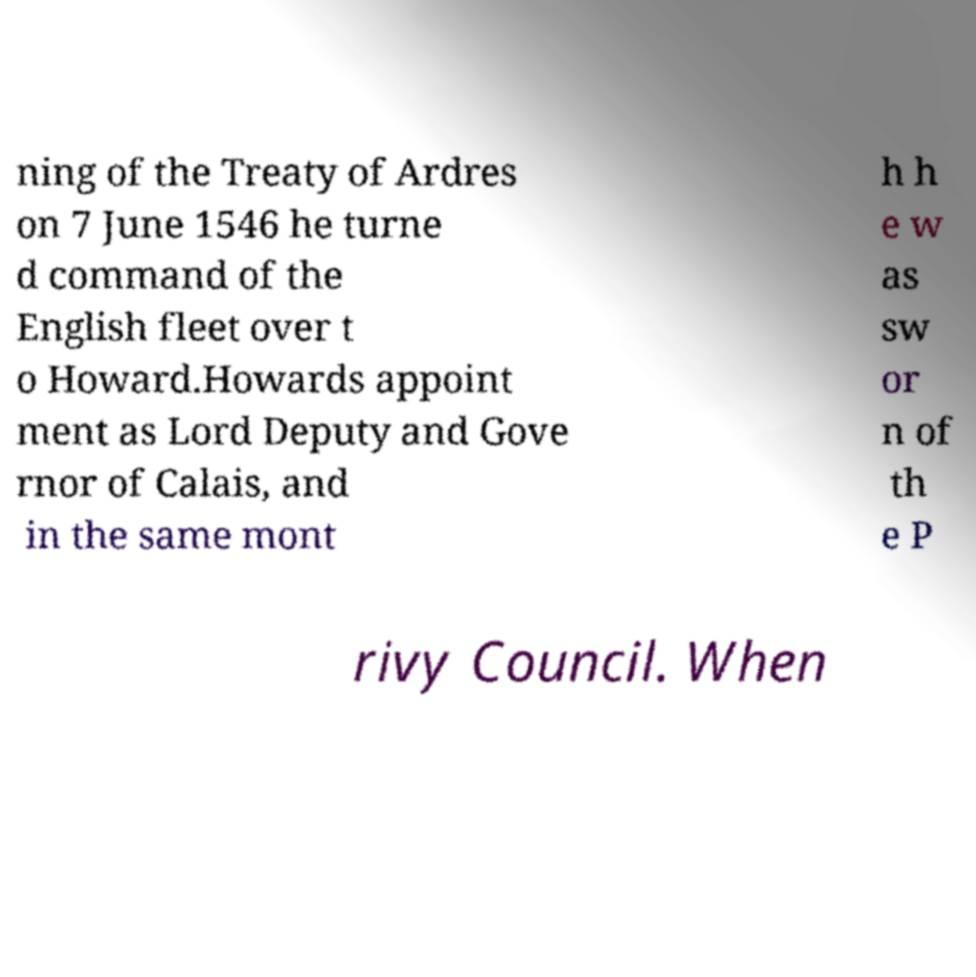Could you assist in decoding the text presented in this image and type it out clearly? ning of the Treaty of Ardres on 7 June 1546 he turne d command of the English fleet over t o Howard.Howards appoint ment as Lord Deputy and Gove rnor of Calais, and in the same mont h h e w as sw or n of th e P rivy Council. When 